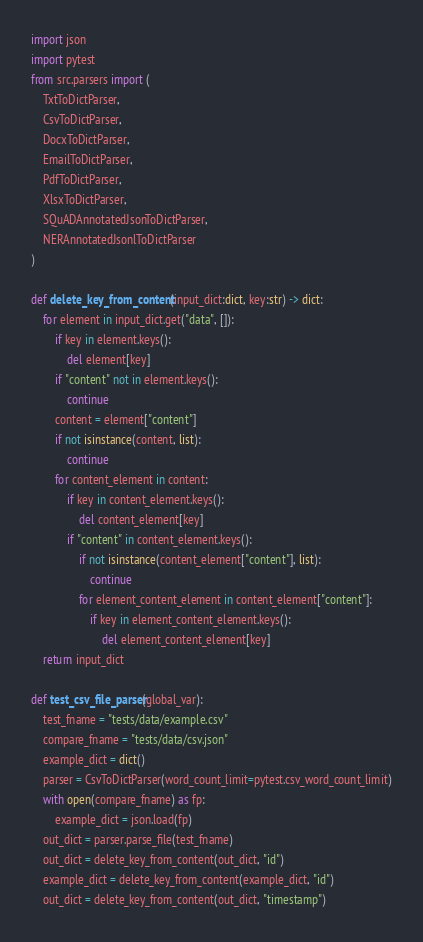Convert code to text. <code><loc_0><loc_0><loc_500><loc_500><_Python_>import json
import pytest
from src.parsers import (
    TxtToDictParser,
    CsvToDictParser,
    DocxToDictParser,
    EmailToDictParser,
    PdfToDictParser,
    XlsxToDictParser,
    SQuADAnnotatedJsonToDictParser,
    NERAnnotatedJsonlToDictParser
)

def delete_key_from_content(input_dict:dict, key:str) -> dict:
    for element in input_dict.get("data", []):
        if key in element.keys():
            del element[key]
        if "content" not in element.keys():
            continue
        content = element["content"]
        if not isinstance(content, list):
            continue
        for content_element in content:
            if key in content_element.keys():
                del content_element[key]
            if "content" in content_element.keys():
                if not isinstance(content_element["content"], list):
                    continue
                for element_content_element in content_element["content"]:
                    if key in element_content_element.keys():
                        del element_content_element[key]
    return input_dict

def test_csv_file_parser(global_var):
    test_fname = "tests/data/example.csv"
    compare_fname = "tests/data/csv.json"
    example_dict = dict()
    parser = CsvToDictParser(word_count_limit=pytest.csv_word_count_limit)
    with open(compare_fname) as fp:
        example_dict = json.load(fp)
    out_dict = parser.parse_file(test_fname)
    out_dict = delete_key_from_content(out_dict, "id")
    example_dict = delete_key_from_content(example_dict, "id")
    out_dict = delete_key_from_content(out_dict, "timestamp")</code> 